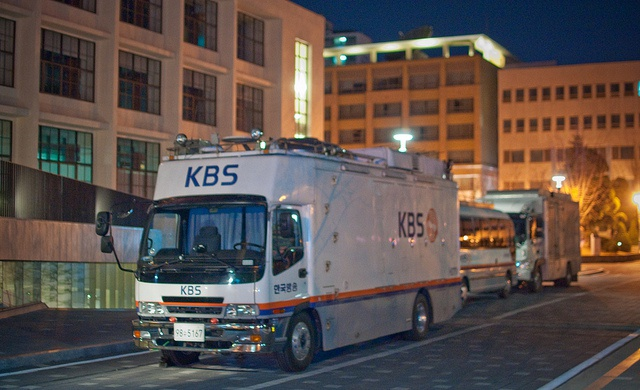Describe the objects in this image and their specific colors. I can see truck in black, gray, and darkgray tones, truck in black, brown, gray, and maroon tones, and bus in black, gray, and maroon tones in this image. 